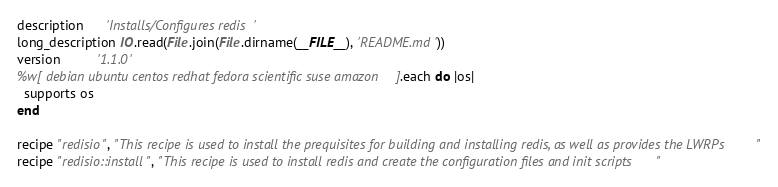Convert code to text. <code><loc_0><loc_0><loc_500><loc_500><_Ruby_>description      'Installs/Configures redis'
long_description IO.read(File.join(File.dirname(__FILE__), 'README.md'))
version          '1.1.0'
%w[ debian ubuntu centos redhat fedora scientific suse amazon].each do |os|
  supports os
end

recipe "redisio", "This recipe is used to install the prequisites for building and installing redis, as well as provides the LWRPs"
recipe "redisio::install", "This recipe is used to install redis and create the configuration files and init scripts"</code> 